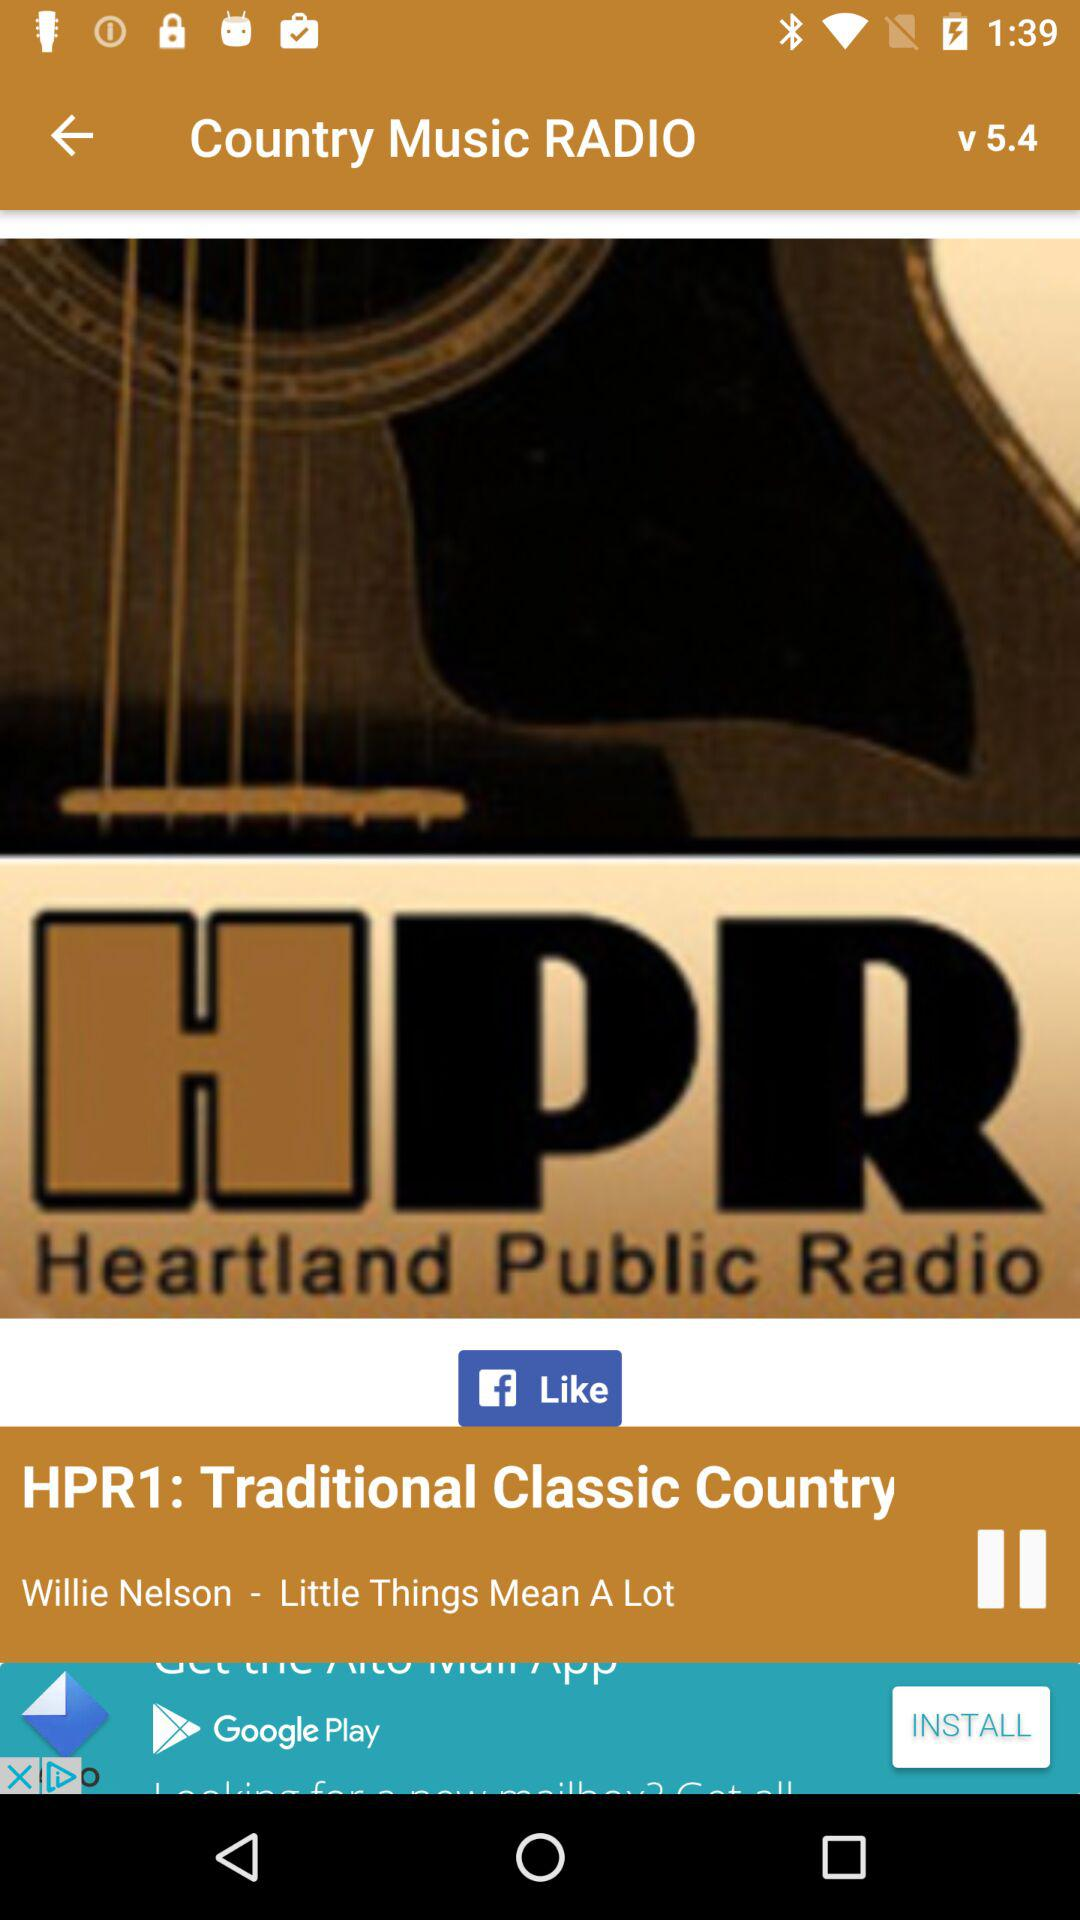What is the name of the radio station? The name of the radio station is "Heartland Public Radio". 